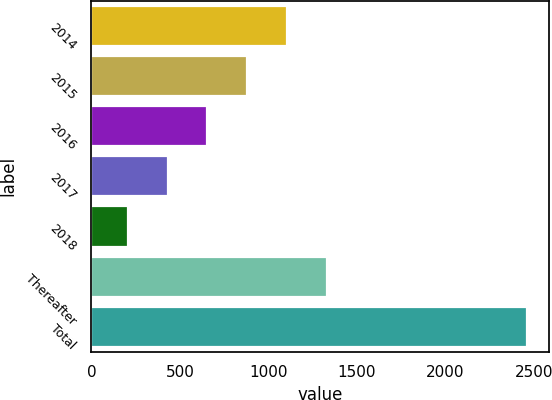Convert chart. <chart><loc_0><loc_0><loc_500><loc_500><bar_chart><fcel>2014<fcel>2015<fcel>2016<fcel>2017<fcel>2018<fcel>Thereafter<fcel>Total<nl><fcel>1107.2<fcel>881.4<fcel>655.6<fcel>429.8<fcel>204<fcel>1333<fcel>2462<nl></chart> 